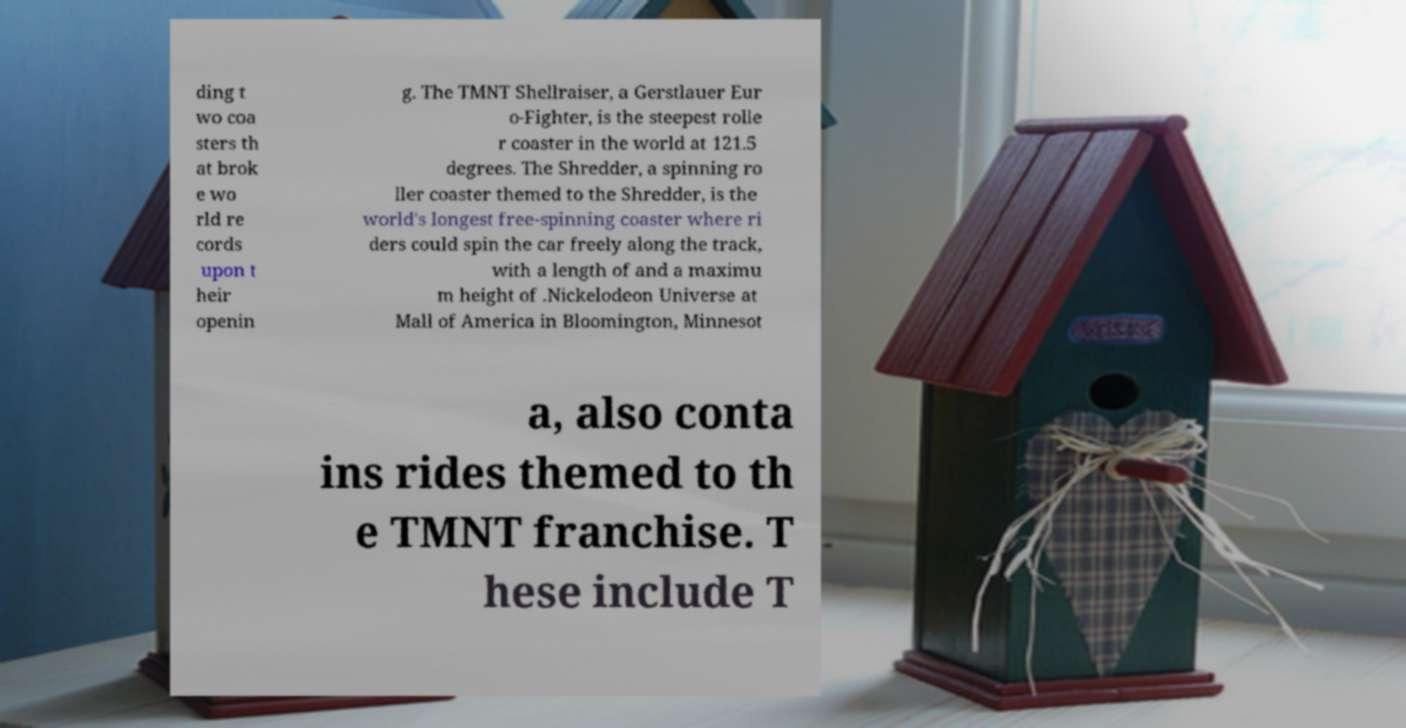Please read and relay the text visible in this image. What does it say? ding t wo coa sters th at brok e wo rld re cords upon t heir openin g. The TMNT Shellraiser, a Gerstlauer Eur o-Fighter, is the steepest rolle r coaster in the world at 121.5 degrees. The Shredder, a spinning ro ller coaster themed to the Shredder, is the world's longest free-spinning coaster where ri ders could spin the car freely along the track, with a length of and a maximu m height of .Nickelodeon Universe at Mall of America in Bloomington, Minnesot a, also conta ins rides themed to th e TMNT franchise. T hese include T 